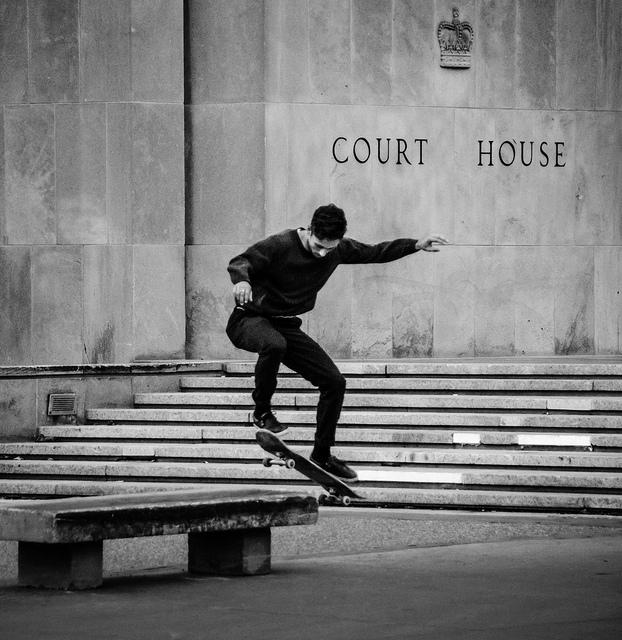In what type setting does the skateboarder skate here?

Choices:
A) desert
B) farm
C) suburban
D) urban urban 